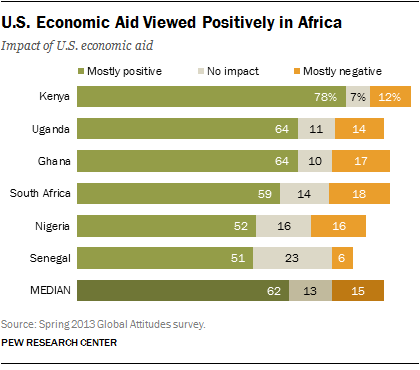Mention a couple of crucial points in this snapshot. The median value of mostly positive numbers is larger than the average of the largest and smallest values. Six countries are included in the chart. 